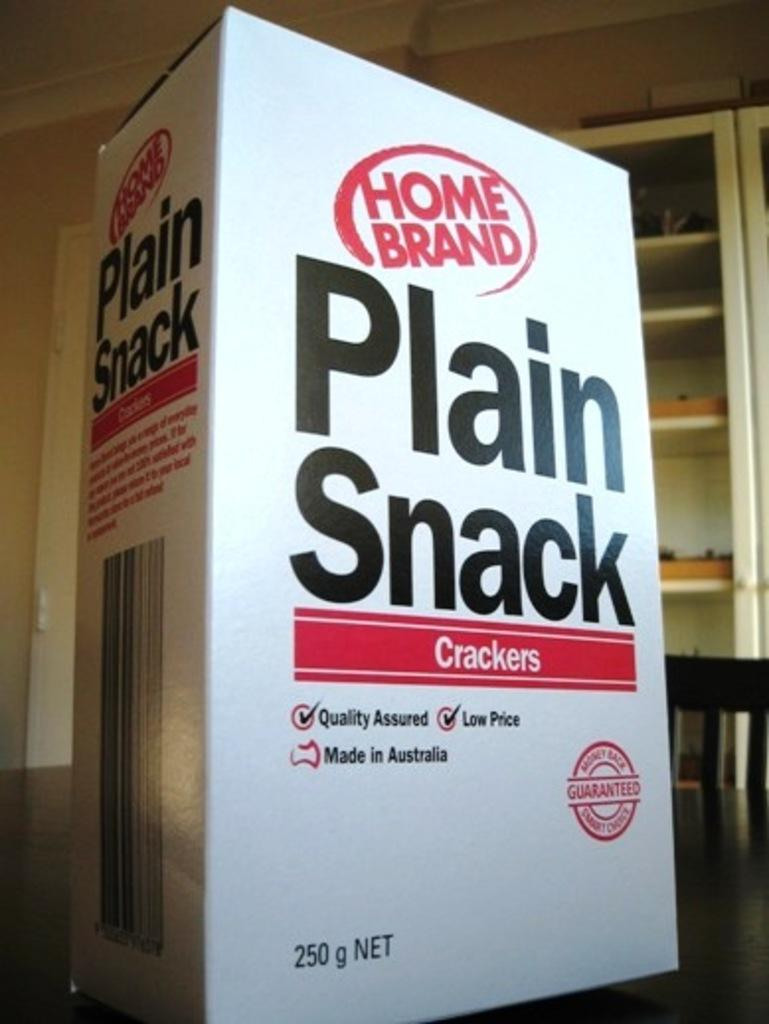<image>
Summarize the visual content of the image. a white box with plain snack crackers in it is sitting on the table 